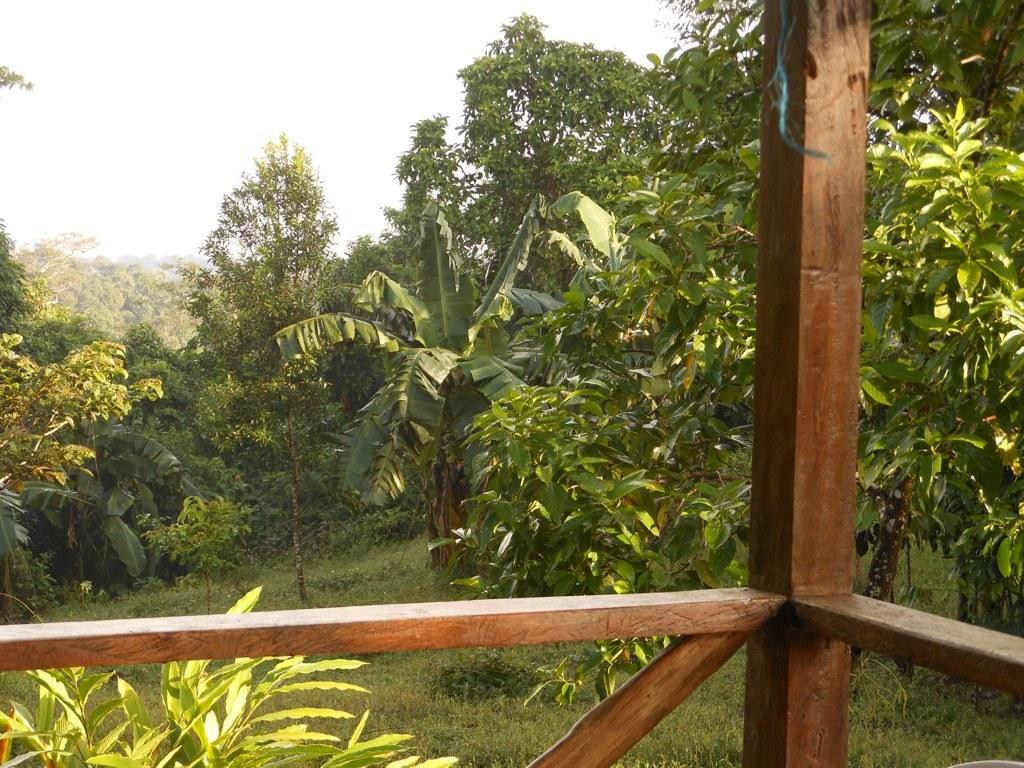What type of barrier is located at the bottom of the image? There is fencing at the bottom of the image. What can be seen behind the fencing? Trees and grass are visible behind the fencing. What is visible at the top of the image? The sky is visible at the top of the image. Can you see any goldfish swimming in the image? There are no goldfish present in the image. What type of discussion is taking place in the image? There is no discussion taking place in the image; it is a still image with no audible content. 